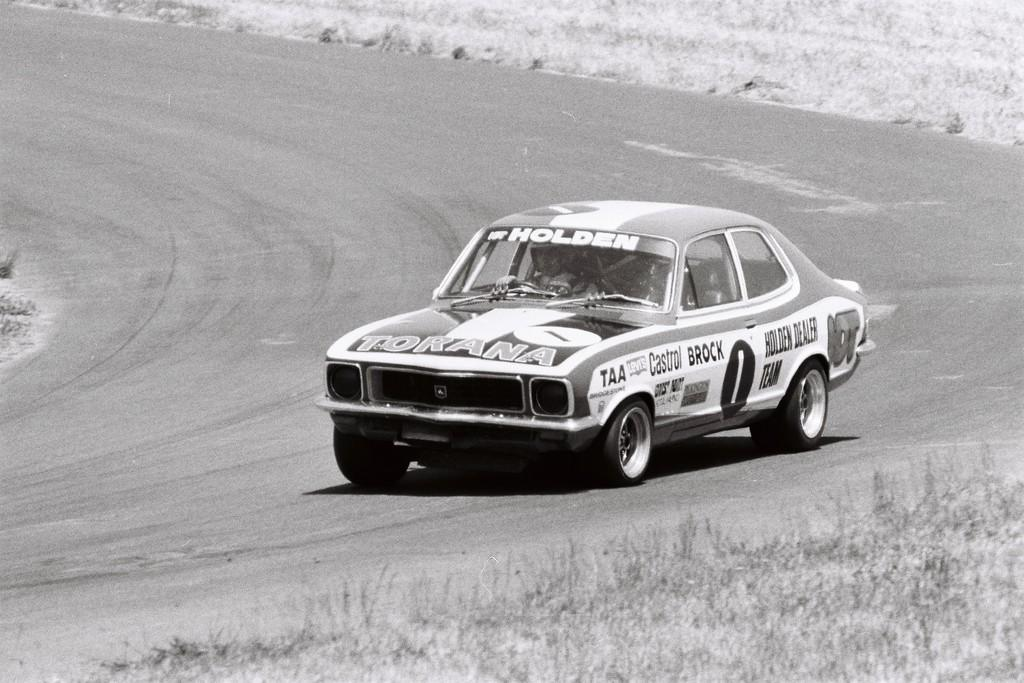What is the main subject of the image? The main subject of the image is a car. What is the car doing in the image? The car is traveling on the road in the image. What type of vegetation can be seen at the bottom of the image? There is grass at the bottom of the image. Is there anyone inside the car? Yes, there is a person in the car. What is the color scheme of the image? The image is black and white. What type of suit is the person in the car wearing in the image? There is no information about the person's clothing in the image, so we cannot determine if they are wearing a suit or not. What nation is depicted in the image? The image does not depict any specific nation; it only shows a car traveling on a road with grass at the bottom. 